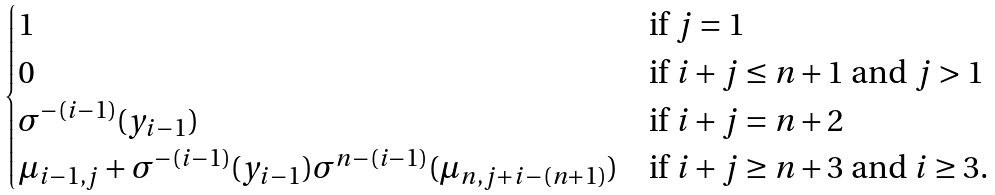Convert formula to latex. <formula><loc_0><loc_0><loc_500><loc_500>\begin{cases} 1 & \text {if $j = 1$} \\ 0 & \text {if $i+j \leq n+1$ and $j > 1$} \\ \sigma ^ { - ( i - 1 ) } ( y _ { i - 1 } ) & \text {if $i + j = n+2$} \\ \mu _ { i - 1 , j } + \sigma ^ { - ( i - 1 ) } ( y _ { i - 1 } ) \sigma ^ { n - ( i - 1 ) } ( \mu _ { n , j + i - ( n + 1 ) } ) & \text {if $i+j \geq n+3$ and $i \geq 3$} . \end{cases}</formula> 